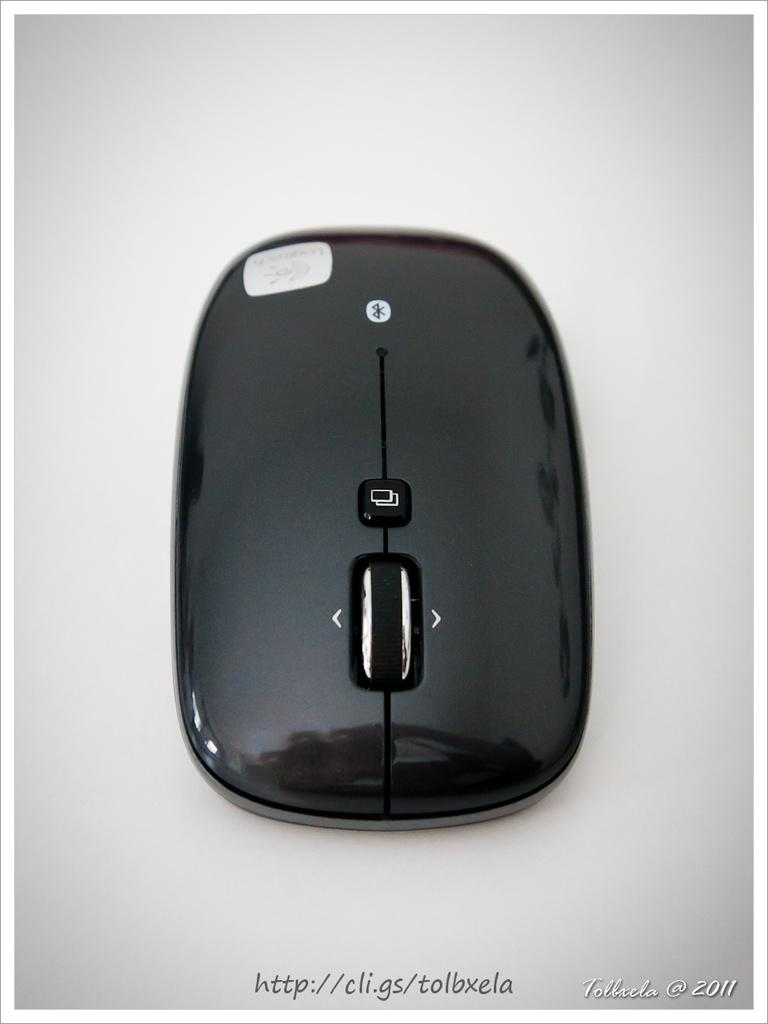<image>
Describe the image concisely. A shiny black Logitech mouse is bluetooth compatible. 